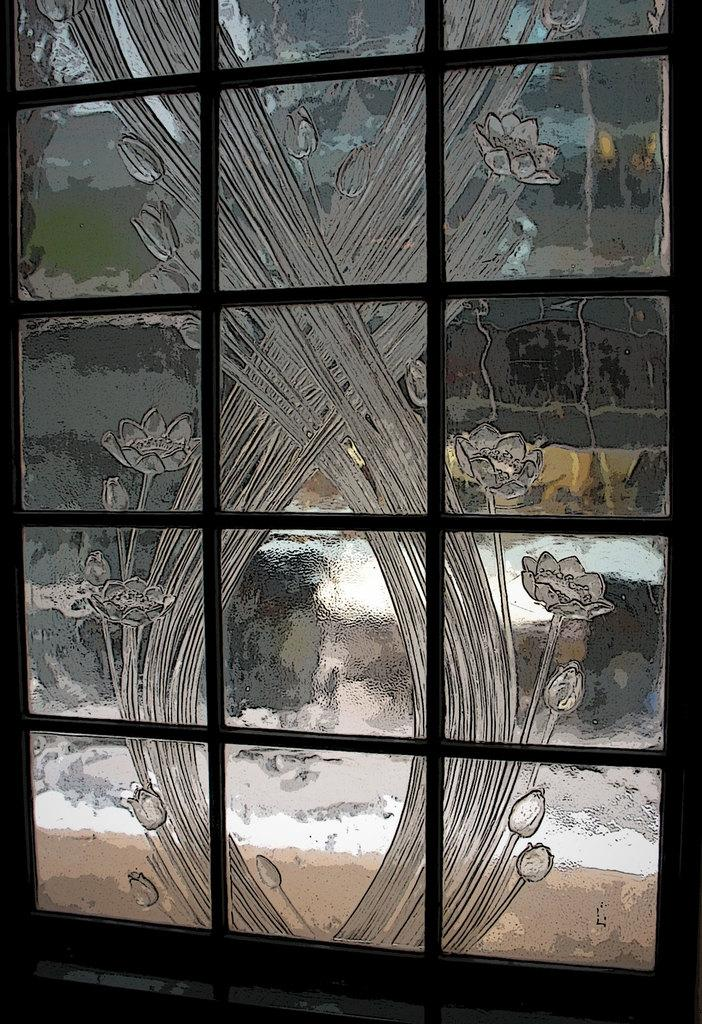What type of art is featured in the image? There is a glass art window in the image. What colors are used in the glass art window? The glass art window is in black and grey color. What arithmetic problem is being solved by the spiders in the image? There are no spiders or arithmetic problems present in the image; it features a glass art window in black and grey color. 